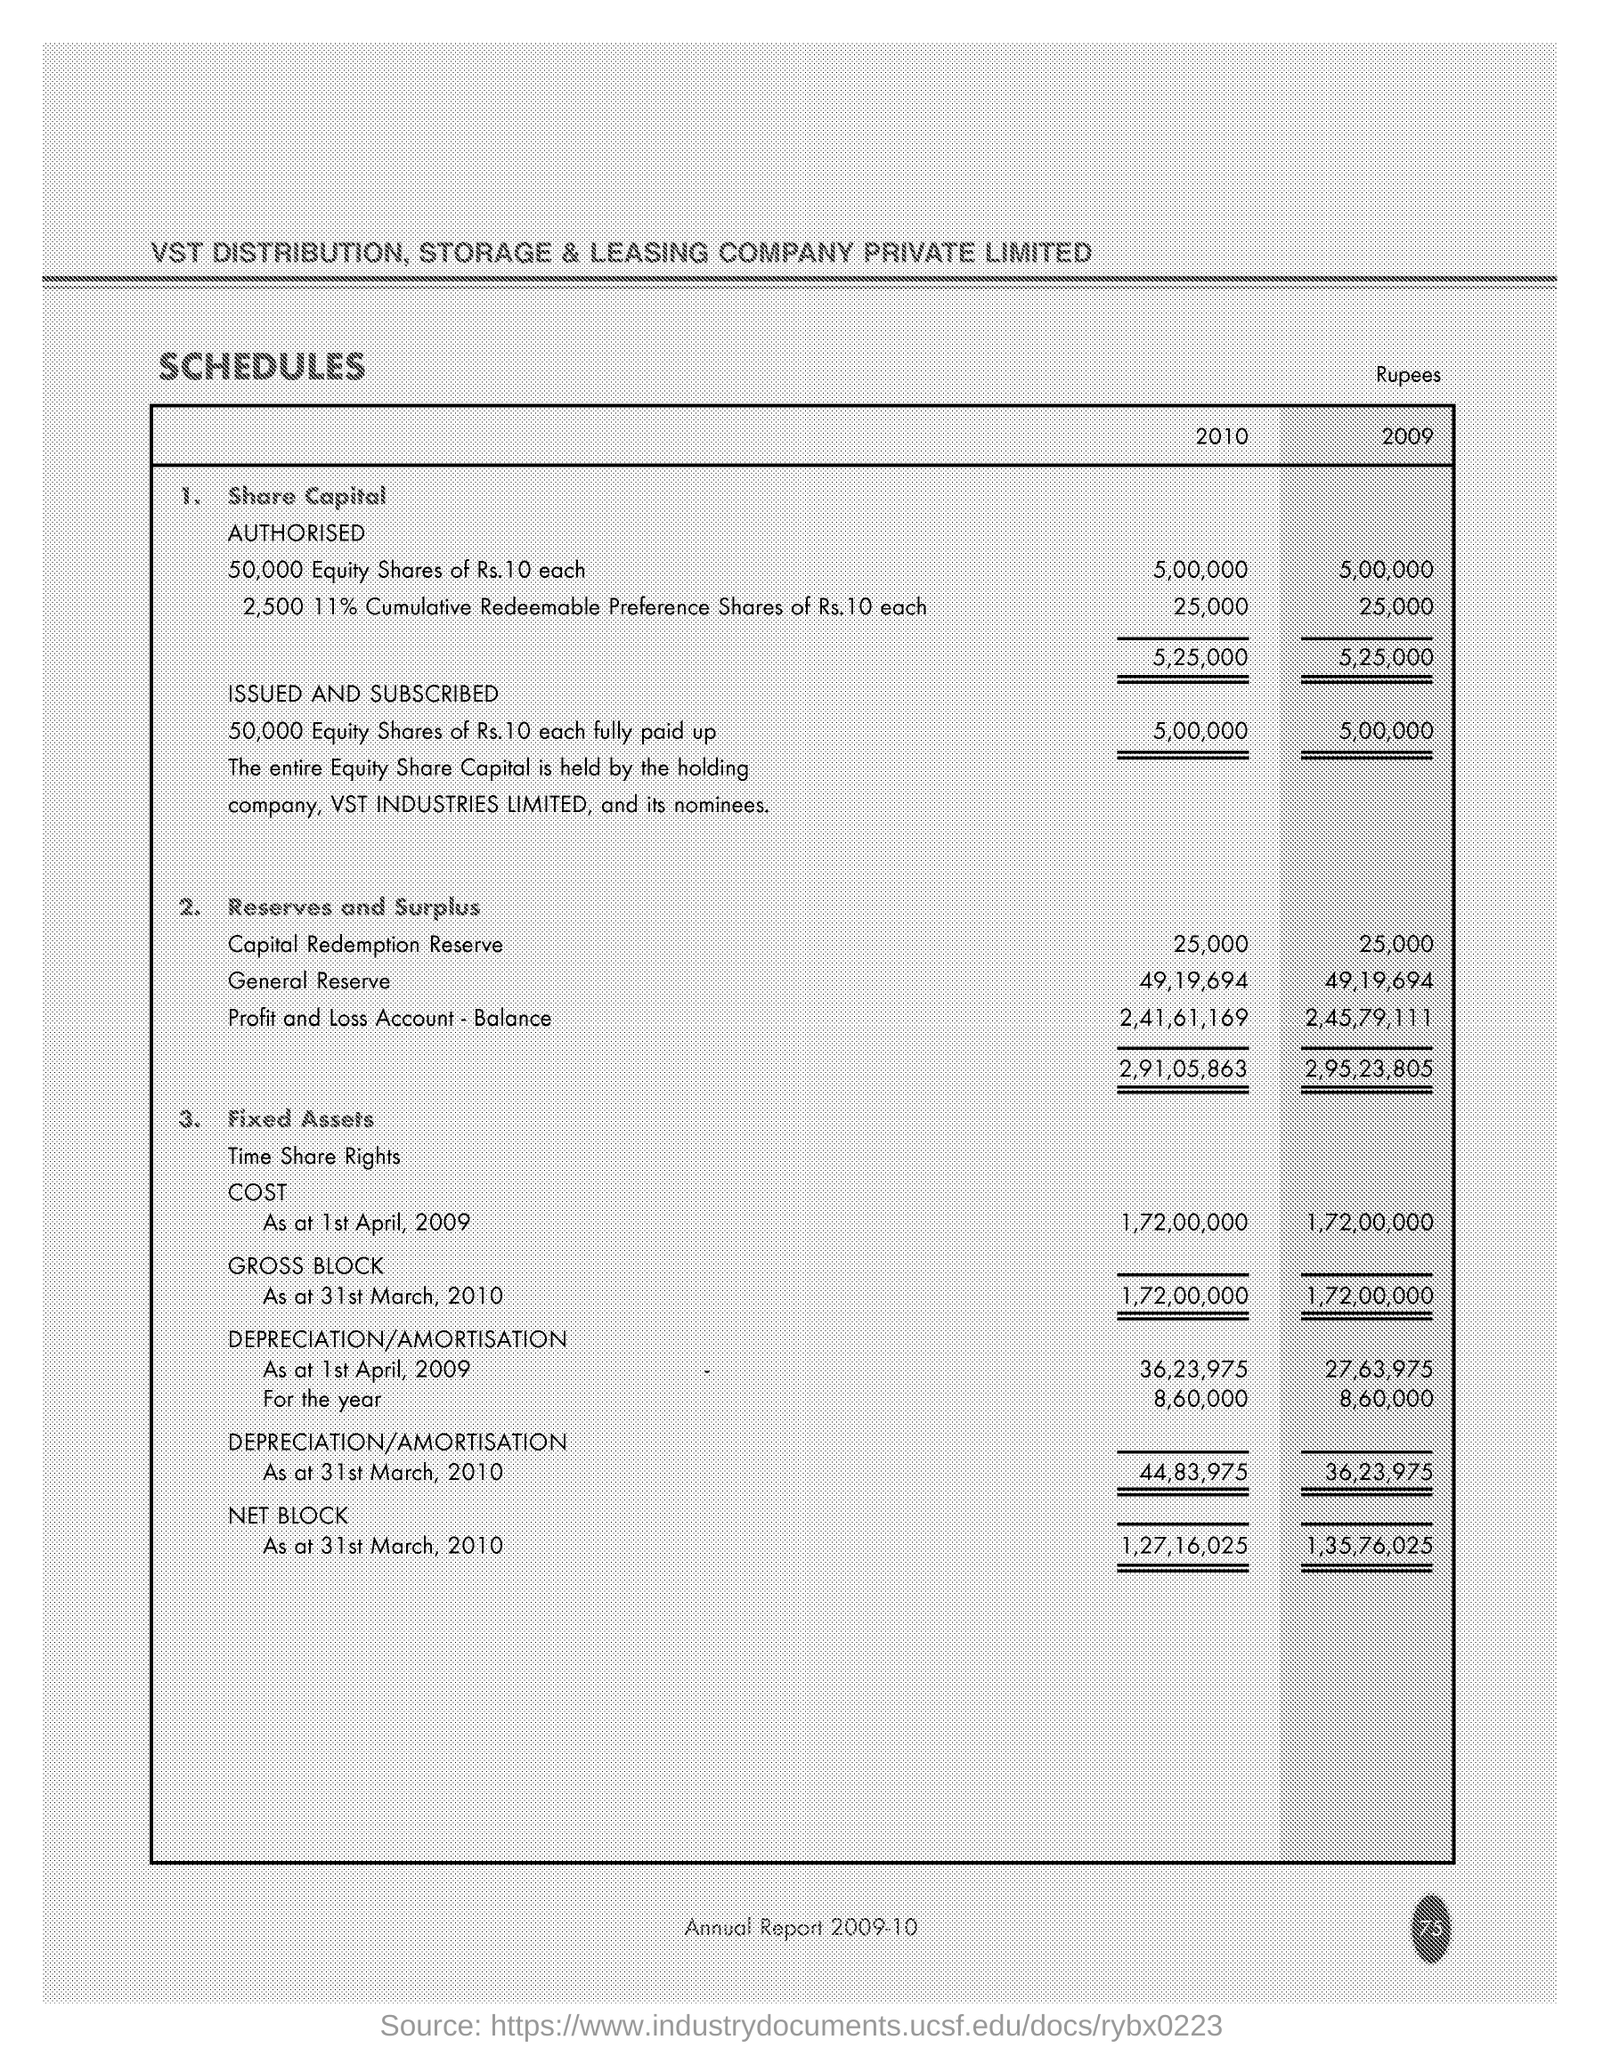Indicate a few pertinent items in this graphic. The company name is VST Distribution. In 2009, the amount of General Reserve was 49,19,694. In 2010, the capital redemption reserve was approximately 25,000. 